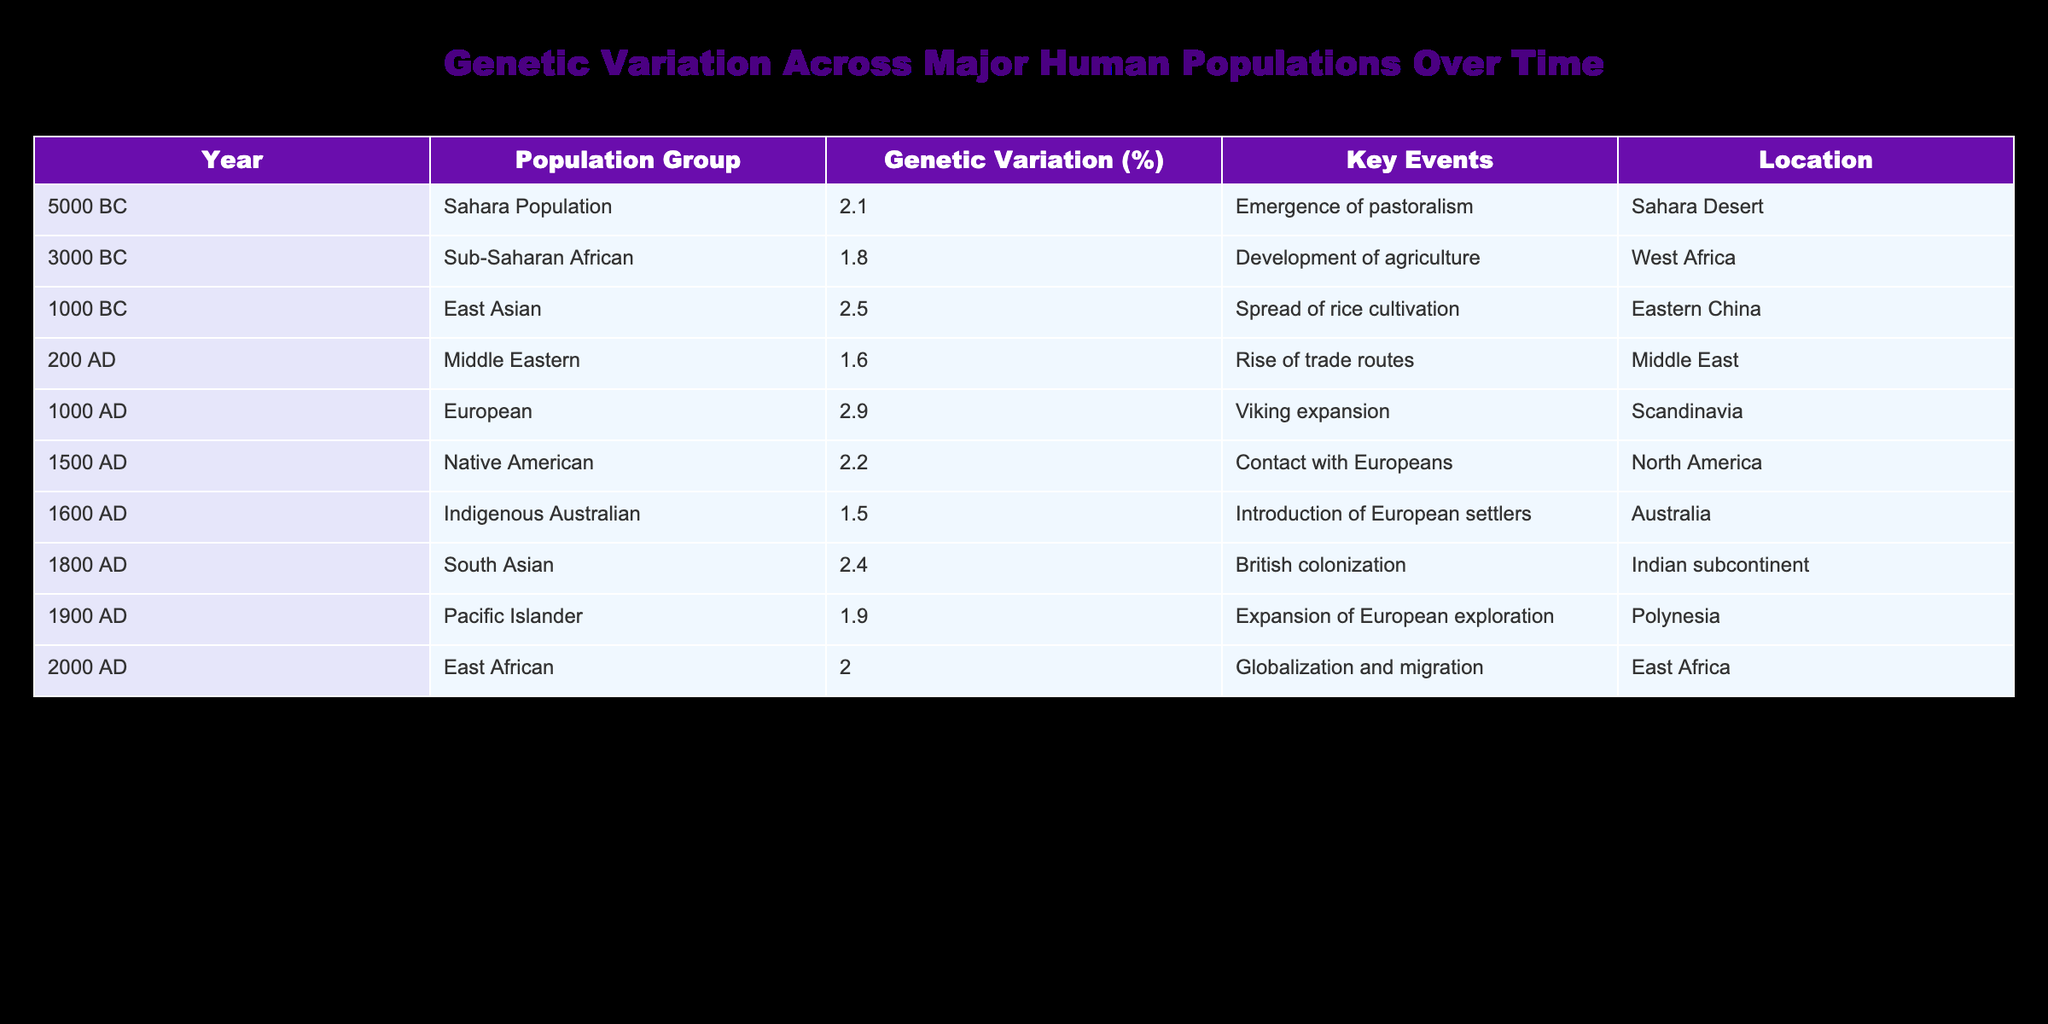What is the genetic variation percentage for the East Asian population in 1000 BC? The table directly lists the data. For the East Asian population in 1000 BC, the genetic variation percentage is indicated as 2.5%.
Answer: 2.5% Which population group had the lowest genetic variation percentage in 1600 AD? The table shows that the Indigenous Australian population had a genetic variation percentage of 1.5% in 1600 AD, which is the lowest compared to other groups in the same year.
Answer: Indigenous Australian What was the average genetic variation percentage for the Native American population group across the given years? The Native American population only appears once in the table in 1500 AD with a genetic variation of 2.2%, therefore the average is simply 2.2%.
Answer: 2.2% Is it true that the Middle Eastern population had a higher genetic variation percentage than the South Asian population in 200 AD? The genetic variation percentage for the Middle Eastern population in 200 AD is 1.6%, while for South Asians in 1800 AD, it is 2.4%. Since 1.6% is less than 2.4%, the statement is false.
Answer: No What was the change in genetic variation percentage from the Sahara Population in 5000 BC to the Sub-Saharan African population in 3000 BC? The Sahara Population had a genetic variation of 2.1% in 5000 BC, and the Sub-Saharan African population had 1.8% in 3000 BC. The change is calculated as 2.1% - 1.8% = 0.3% decrease.
Answer: 0.3% decrease Which population groups had genetic variation percentages above 2.0%? Looking through the table, the populations with percentages above 2.0% include East Asian (2.5%), European (2.9%), Native American (2.2%), and South Asian (2.4%). Therefore, the groups are East Asian, European, Native American, and South Asian.
Answer: East Asian, European, Native American, South Asian What is the difference in genetic variation percentage between the Pacific Islander population in 1900 AD and the East African population in 2000 AD? The Pacific Islander population has a genetic variation of 1.9% in 1900 AD, while the East African population has 2.0% in 2000 AD. The difference is calculated as 2.0% - 1.9% = 0.1%.
Answer: 0.1% How many population groups listed in the table experienced key historical events related to colonization? The table indicates that the Native American (1500 AD) and South Asian (1800 AD) groups experienced colonization events. Therefore, 2 population groups are related to this theme.
Answer: 2 What year had the highest recorded genetic variation percentage in the table? The European population in 1000 AD had the highest genetic variation percentage of 2.9%, which is greater than all other listed years.
Answer: 1000 AD 